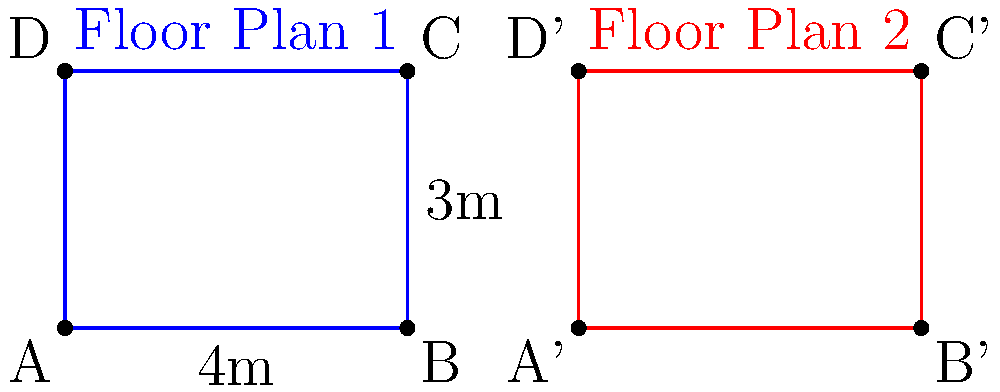As a professional wedding photographer, you're often asked to assess different venue layouts. Given two rectangular floor plans for potential wedding venues, determine if they are congruent. Floor Plan 1 has dimensions of 4m by 3m, while Floor Plan 2's dimensions are not explicitly stated. Which additional piece of information would you need to conclusively determine if these floor plans are congruent? To determine if two rectangles are congruent, we need to compare both their shape and size. Let's approach this step-by-step:

1. We know that Floor Plan 1 is a rectangle with dimensions 4m by 3m.

2. Floor Plan 2 is also a rectangle, but we don't have its dimensions.

3. For two rectangles to be congruent, they must have the same length and width (in either order).

4. We already know one dimension of Floor Plan 1 (4m). If we knew either the length or width of Floor Plan 2, we could determine if it matches either dimension of Floor Plan 1.

5. If one dimension matches, we would then need to check if the other dimension also matches. However, since rectangles have only two dimensions, knowing one dimension of Floor Plan 2 would be sufficient to determine congruence.

6. If the known dimension of Floor Plan 2 matches neither 4m nor 3m, we can immediately conclude the floor plans are not congruent.

7. If the known dimension matches either 4m or 3m, we can infer the other dimension (due to the rectangular shape) and determine congruence.

Therefore, knowing either the length or width of Floor Plan 2 would be sufficient to determine if the two floor plans are congruent.
Answer: Either the length or width of Floor Plan 2 